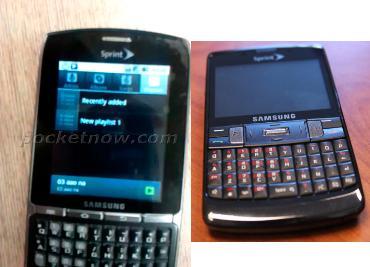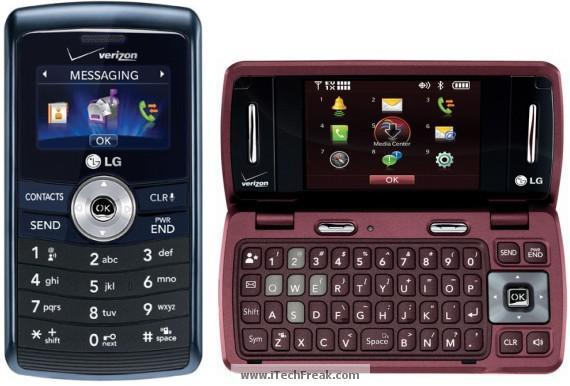The first image is the image on the left, the second image is the image on the right. Considering the images on both sides, is "The left image contains no more than two cell phones." valid? Answer yes or no. Yes. The first image is the image on the left, the second image is the image on the right. Examine the images to the left and right. Is the description "A cell phone opens horizontally in the image on the right." accurate? Answer yes or no. Yes. 